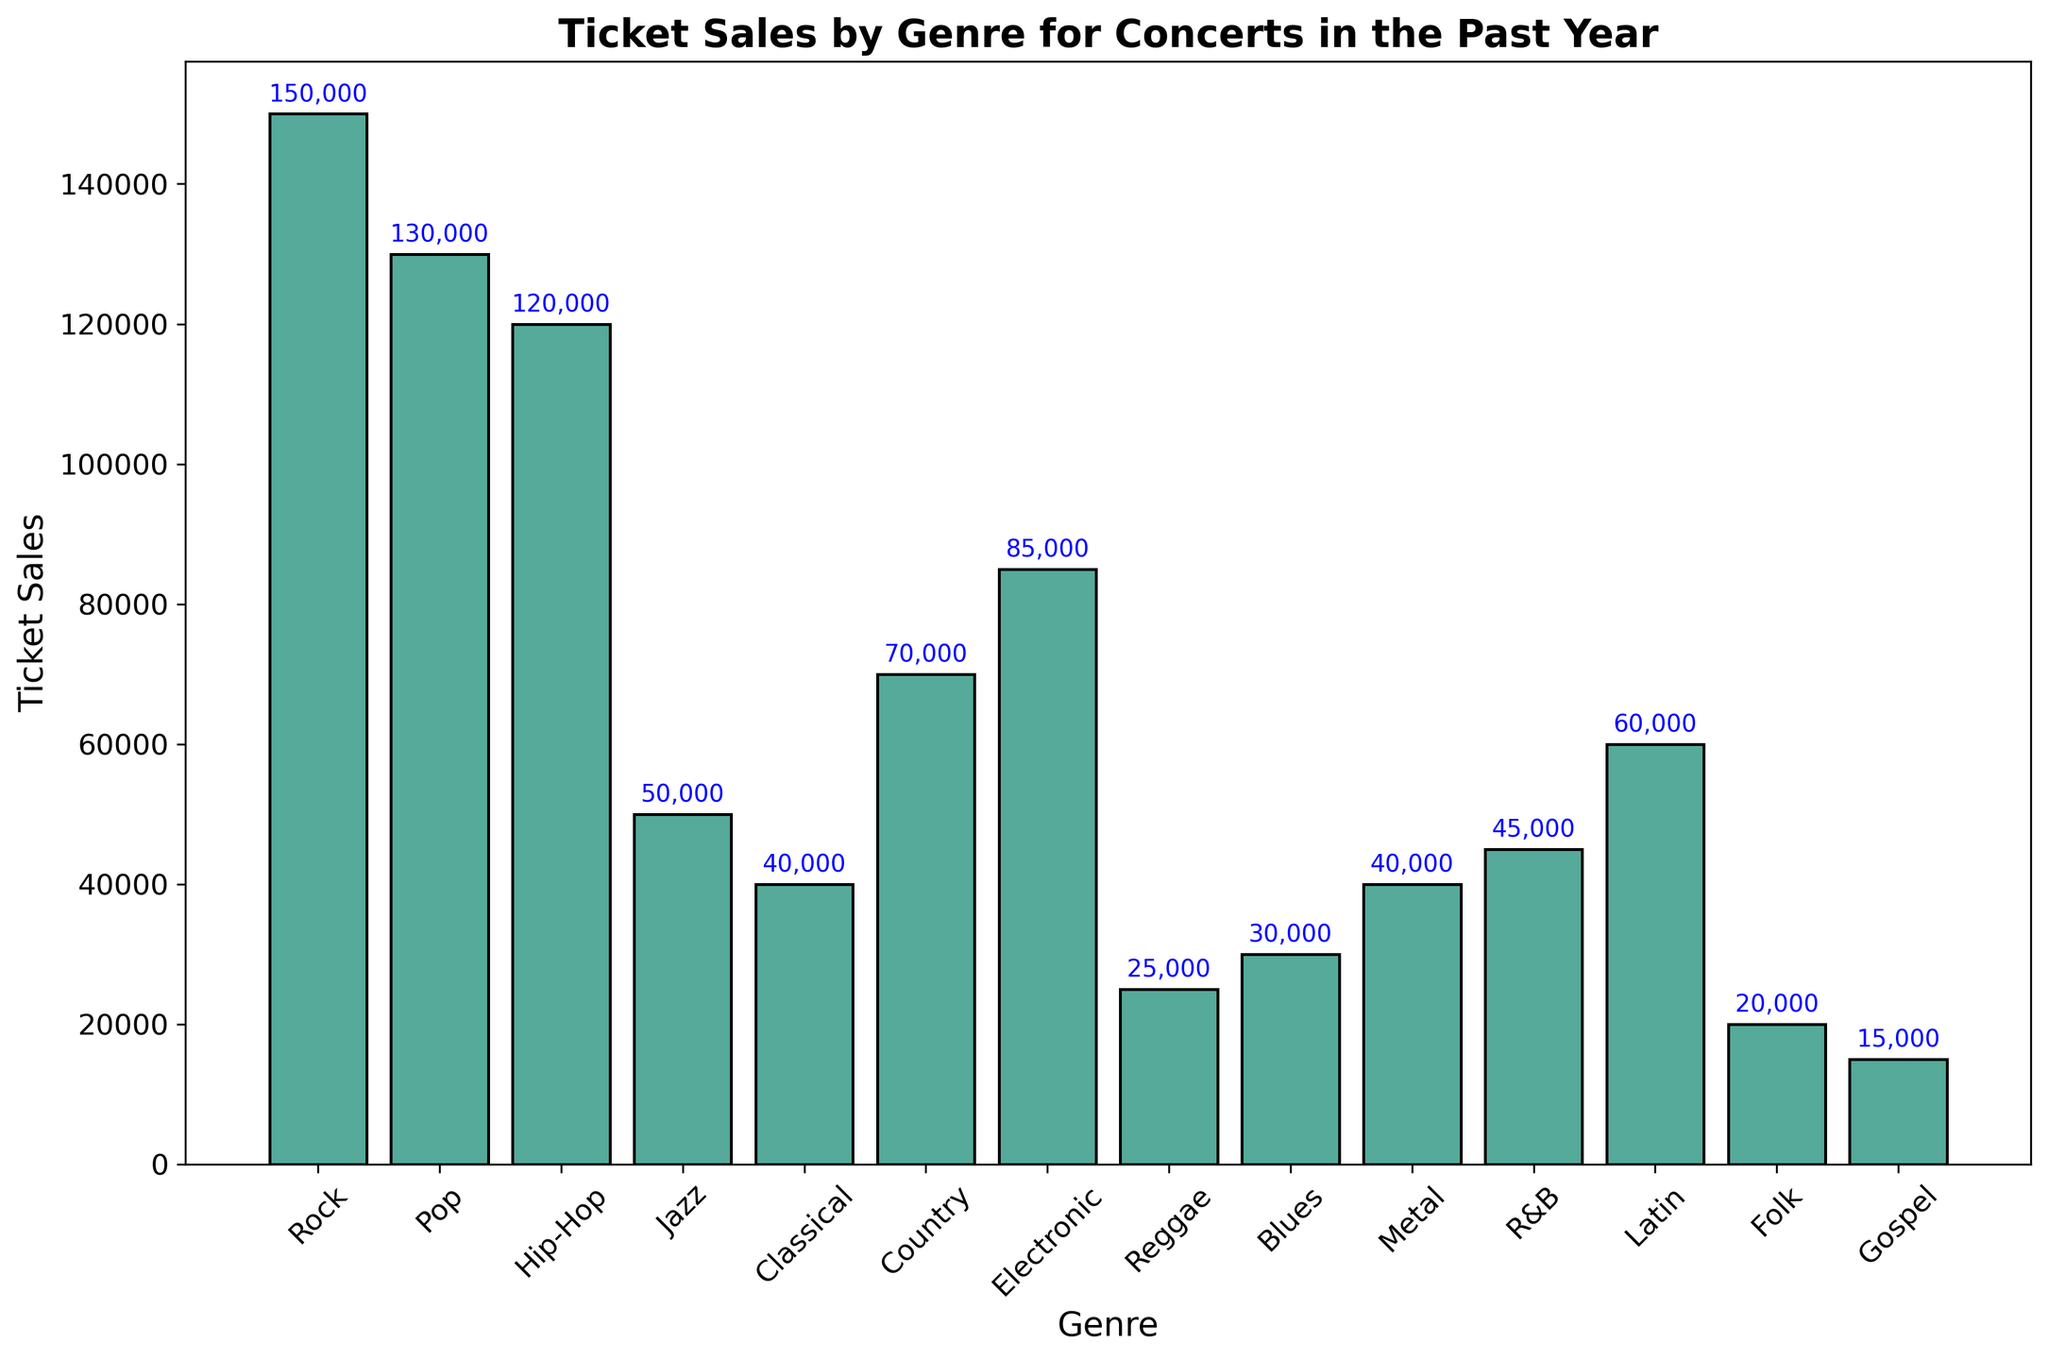What genre has the highest ticket sales? The figure shows that the Rock genre has the tallest bar among all the genres, indicating it has the highest ticket sales.
Answer: Rock Which genre has lower ticket sales, Jazz or Hip-Hop? By comparing the bars of Jazz and Hip-Hop, it's evident that the Jazz bar is shorter than the Hip-Hop bar, indicating fewer ticket sales for Jazz.
Answer: Jazz How much more are the Rock ticket sales compared to the Latin ticket sales? The bar for Rock shows 150,000 ticket sales and the bar for Latin shows 60,000 ticket sales. The difference is 150,000 - 60,000 = 90,000.
Answer: 90,000 What is the total ticket sales for Classical, Country, and Electronic genres combined? Adding the ticket sales for Classical (40,000), Country (70,000), and Electronic (85,000) will give the total: 40,000 + 70,000 + 85,000 = 195,000.
Answer: 195,000 Which genre has greater ticket sales, R&B or Blues? By comparing the heights of the bars for R&B and Blues, the R&B bar is slightly taller indicating greater ticket sales for R&B.
Answer: R&B What is the combined ticket sales for the three least popular genres? The three genres with the shortest bars are Gospel (15,000), Folk (20,000), and Reggae (25,000). Adding these gives: 15,000 + 20,000 + 25,000 = 60,000.
Answer: 60,000 What is the average ticket sales for the genres listed? Adding all ticket sales: 150,000 + 130,000 + 120,000 + 50,000 + 40,000 + 70,000 + 85,000 + 25,000 + 30,000 + 40,000 + 45,000 + 60,000 + 20,000 + 15,000 = 880,000. There are 14 genres, so the average is 880,000 / 14 ≈ 62,857.
Answer: 62,857 What is the difference in ticket sales between the most popular and least popular genres? The Rock genre has the highest ticket sales at 150,000, and the Gospel genre has the lowest at 15,000. The difference is 150,000 - 15,000 = 135,000.
Answer: 135,000 What proportion of the total ticket sales does the Hip-Hop genre represent? Total ticket sales sum up to 880,000. Hip-Hop has 120,000 ticket sales. So, the proportion is 120,000 / 880,000 ≈ 0.136 or 13.6%.
Answer: 13.6% Which genre's ticket sales are approximately halfway between Metal and Pop? Metal has 40,000 ticket sales and Pop has 130,000. Halfway value is (130,000 + 40,000) / 2 = 85,000. The genre close to 85,000 is Electronic.
Answer: Electronic 